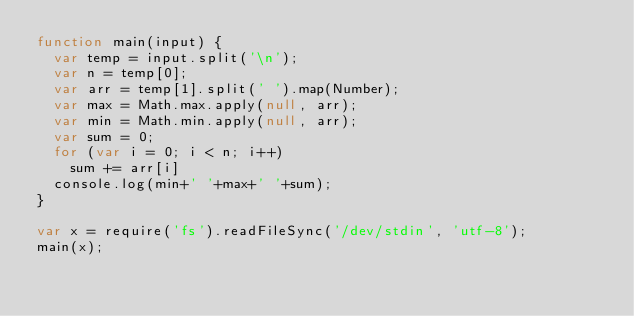Convert code to text. <code><loc_0><loc_0><loc_500><loc_500><_JavaScript_>function main(input) {
  var temp = input.split('\n');
  var n = temp[0];
  var arr = temp[1].split(' ').map(Number);
  var max = Math.max.apply(null, arr);
  var min = Math.min.apply(null, arr);
  var sum = 0;
  for (var i = 0; i < n; i++)
    sum += arr[i]
  console.log(min+' '+max+' '+sum);
}

var x = require('fs').readFileSync('/dev/stdin', 'utf-8');
main(x);
</code> 